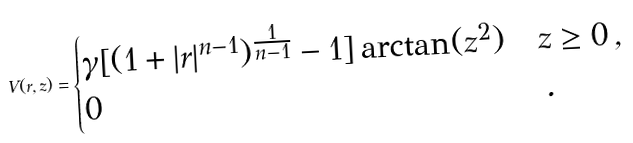Convert formula to latex. <formula><loc_0><loc_0><loc_500><loc_500>V ( r , z ) = \begin{cases} \gamma [ ( 1 + | r | ^ { n - 1 } ) ^ { \frac { 1 } { n - 1 } } - 1 ] \arctan ( z ^ { 2 } ) & z \geq 0 \, , \\ 0 & \, . \end{cases}</formula> 